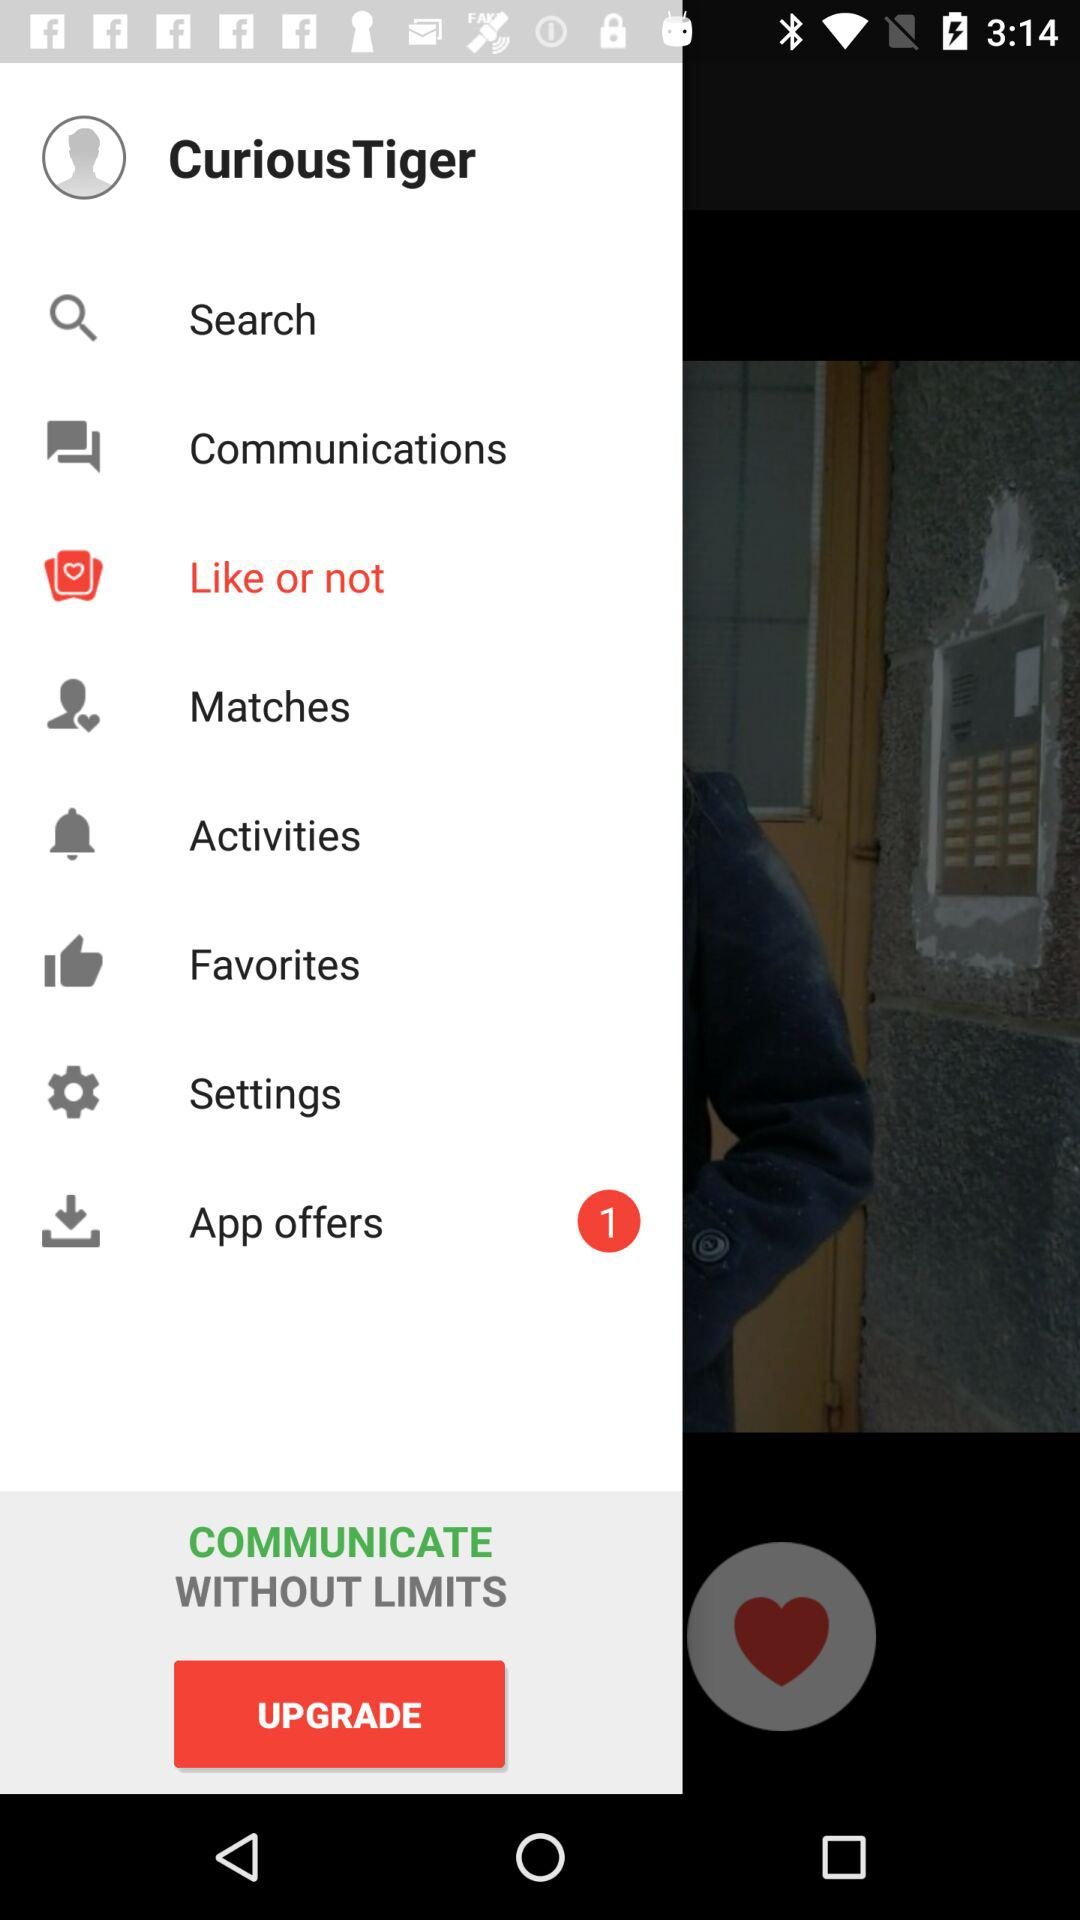How many unread notifications are there for "App offers"? There is 1 notification. 